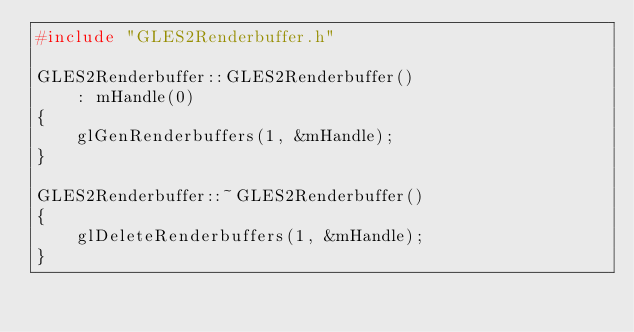Convert code to text. <code><loc_0><loc_0><loc_500><loc_500><_C++_>#include "GLES2Renderbuffer.h"

GLES2Renderbuffer::GLES2Renderbuffer()
    : mHandle(0)
{
    glGenRenderbuffers(1, &mHandle);
}

GLES2Renderbuffer::~GLES2Renderbuffer()
{
    glDeleteRenderbuffers(1, &mHandle);
}
</code> 